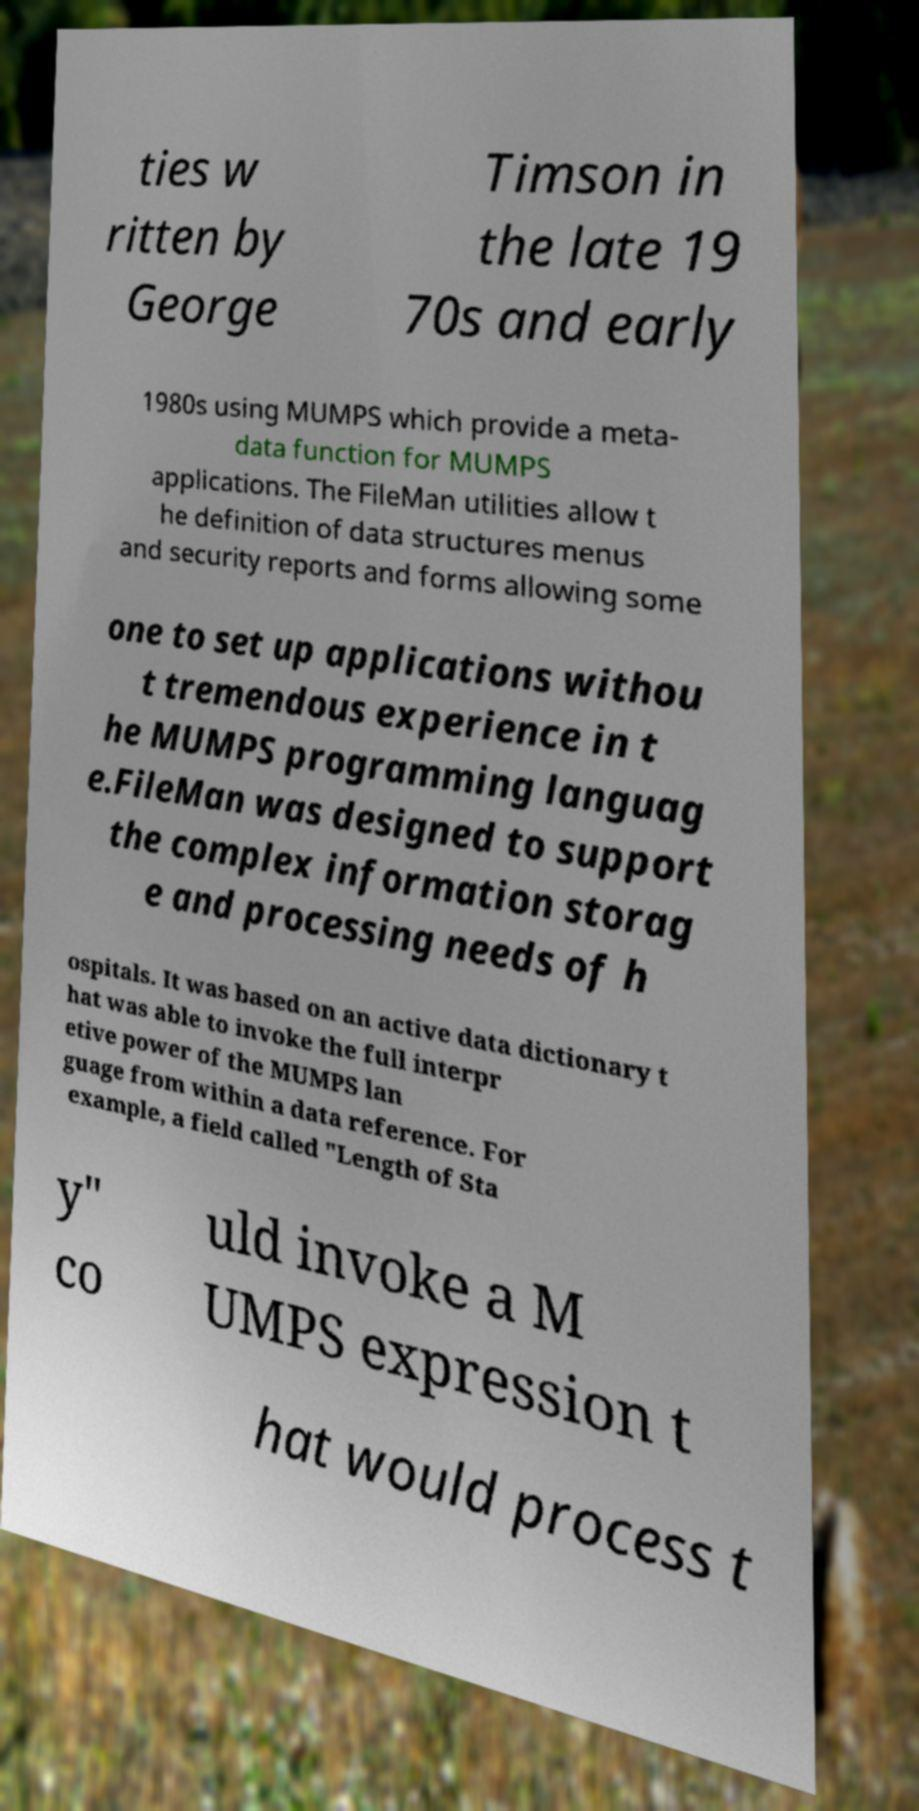Can you read and provide the text displayed in the image?This photo seems to have some interesting text. Can you extract and type it out for me? ties w ritten by George Timson in the late 19 70s and early 1980s using MUMPS which provide a meta- data function for MUMPS applications. The FileMan utilities allow t he definition of data structures menus and security reports and forms allowing some one to set up applications withou t tremendous experience in t he MUMPS programming languag e.FileMan was designed to support the complex information storag e and processing needs of h ospitals. It was based on an active data dictionary t hat was able to invoke the full interpr etive power of the MUMPS lan guage from within a data reference. For example, a field called "Length of Sta y" co uld invoke a M UMPS expression t hat would process t 